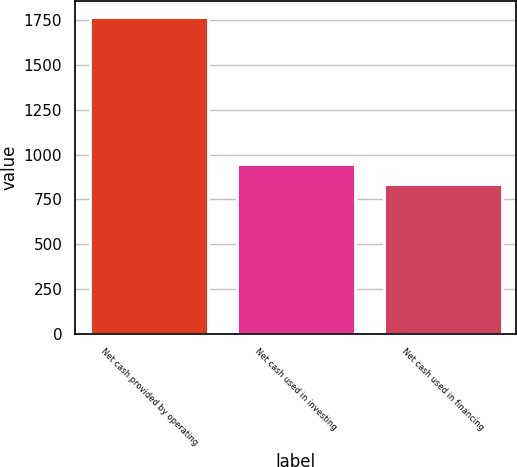Convert chart. <chart><loc_0><loc_0><loc_500><loc_500><bar_chart><fcel>Net cash provided by operating<fcel>Net cash used in investing<fcel>Net cash used in financing<nl><fcel>1766.7<fcel>950.2<fcel>838.5<nl></chart> 